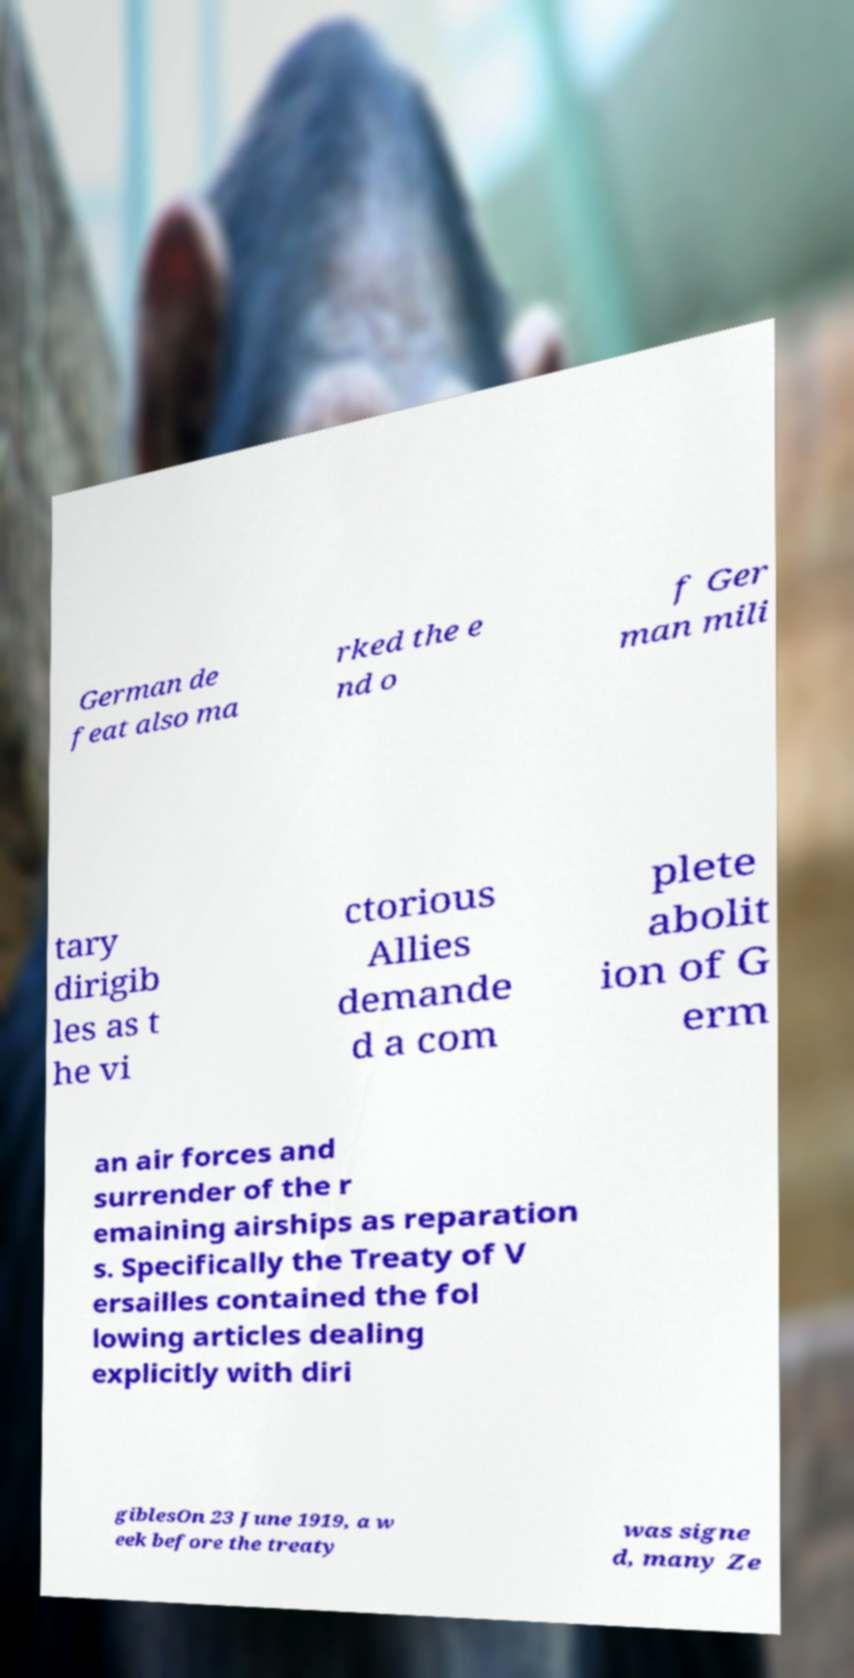There's text embedded in this image that I need extracted. Can you transcribe it verbatim? German de feat also ma rked the e nd o f Ger man mili tary dirigib les as t he vi ctorious Allies demande d a com plete abolit ion of G erm an air forces and surrender of the r emaining airships as reparation s. Specifically the Treaty of V ersailles contained the fol lowing articles dealing explicitly with diri giblesOn 23 June 1919, a w eek before the treaty was signe d, many Ze 